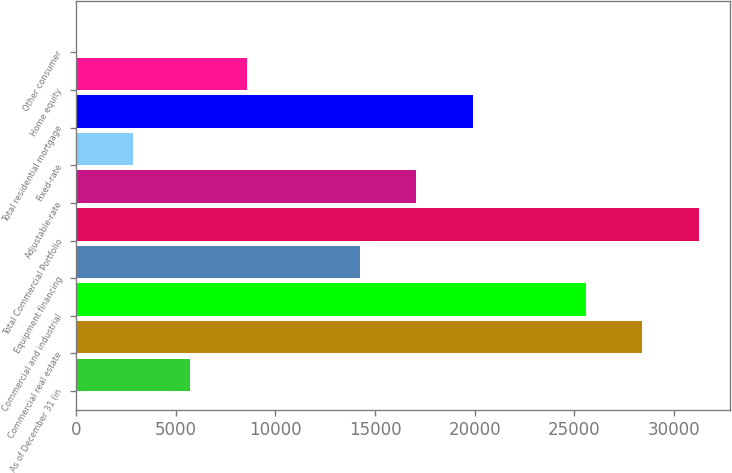<chart> <loc_0><loc_0><loc_500><loc_500><bar_chart><fcel>As of December 31 (in<fcel>Commercial real estate<fcel>Commercial and industrial<fcel>Equipment financing<fcel>Total Commercial Portfolio<fcel>Adjustable-rate<fcel>Fixed-rate<fcel>Total residential mortgage<fcel>Home equity<fcel>Other consumer<nl><fcel>5721.7<fcel>28410.9<fcel>25574.8<fcel>14230.1<fcel>31247<fcel>17066.3<fcel>2885.55<fcel>19902.5<fcel>8557.85<fcel>49.4<nl></chart> 